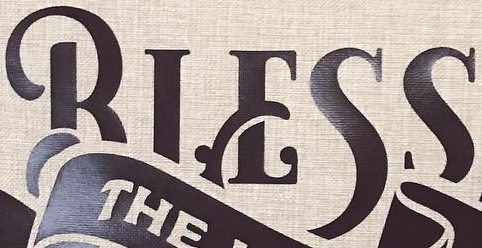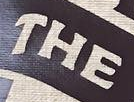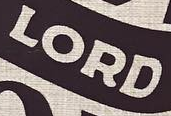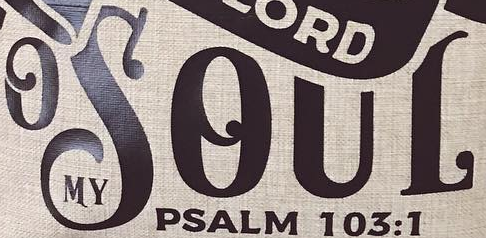Read the text from these images in sequence, separated by a semicolon. BIESS; THE; LORD; OSOUL 